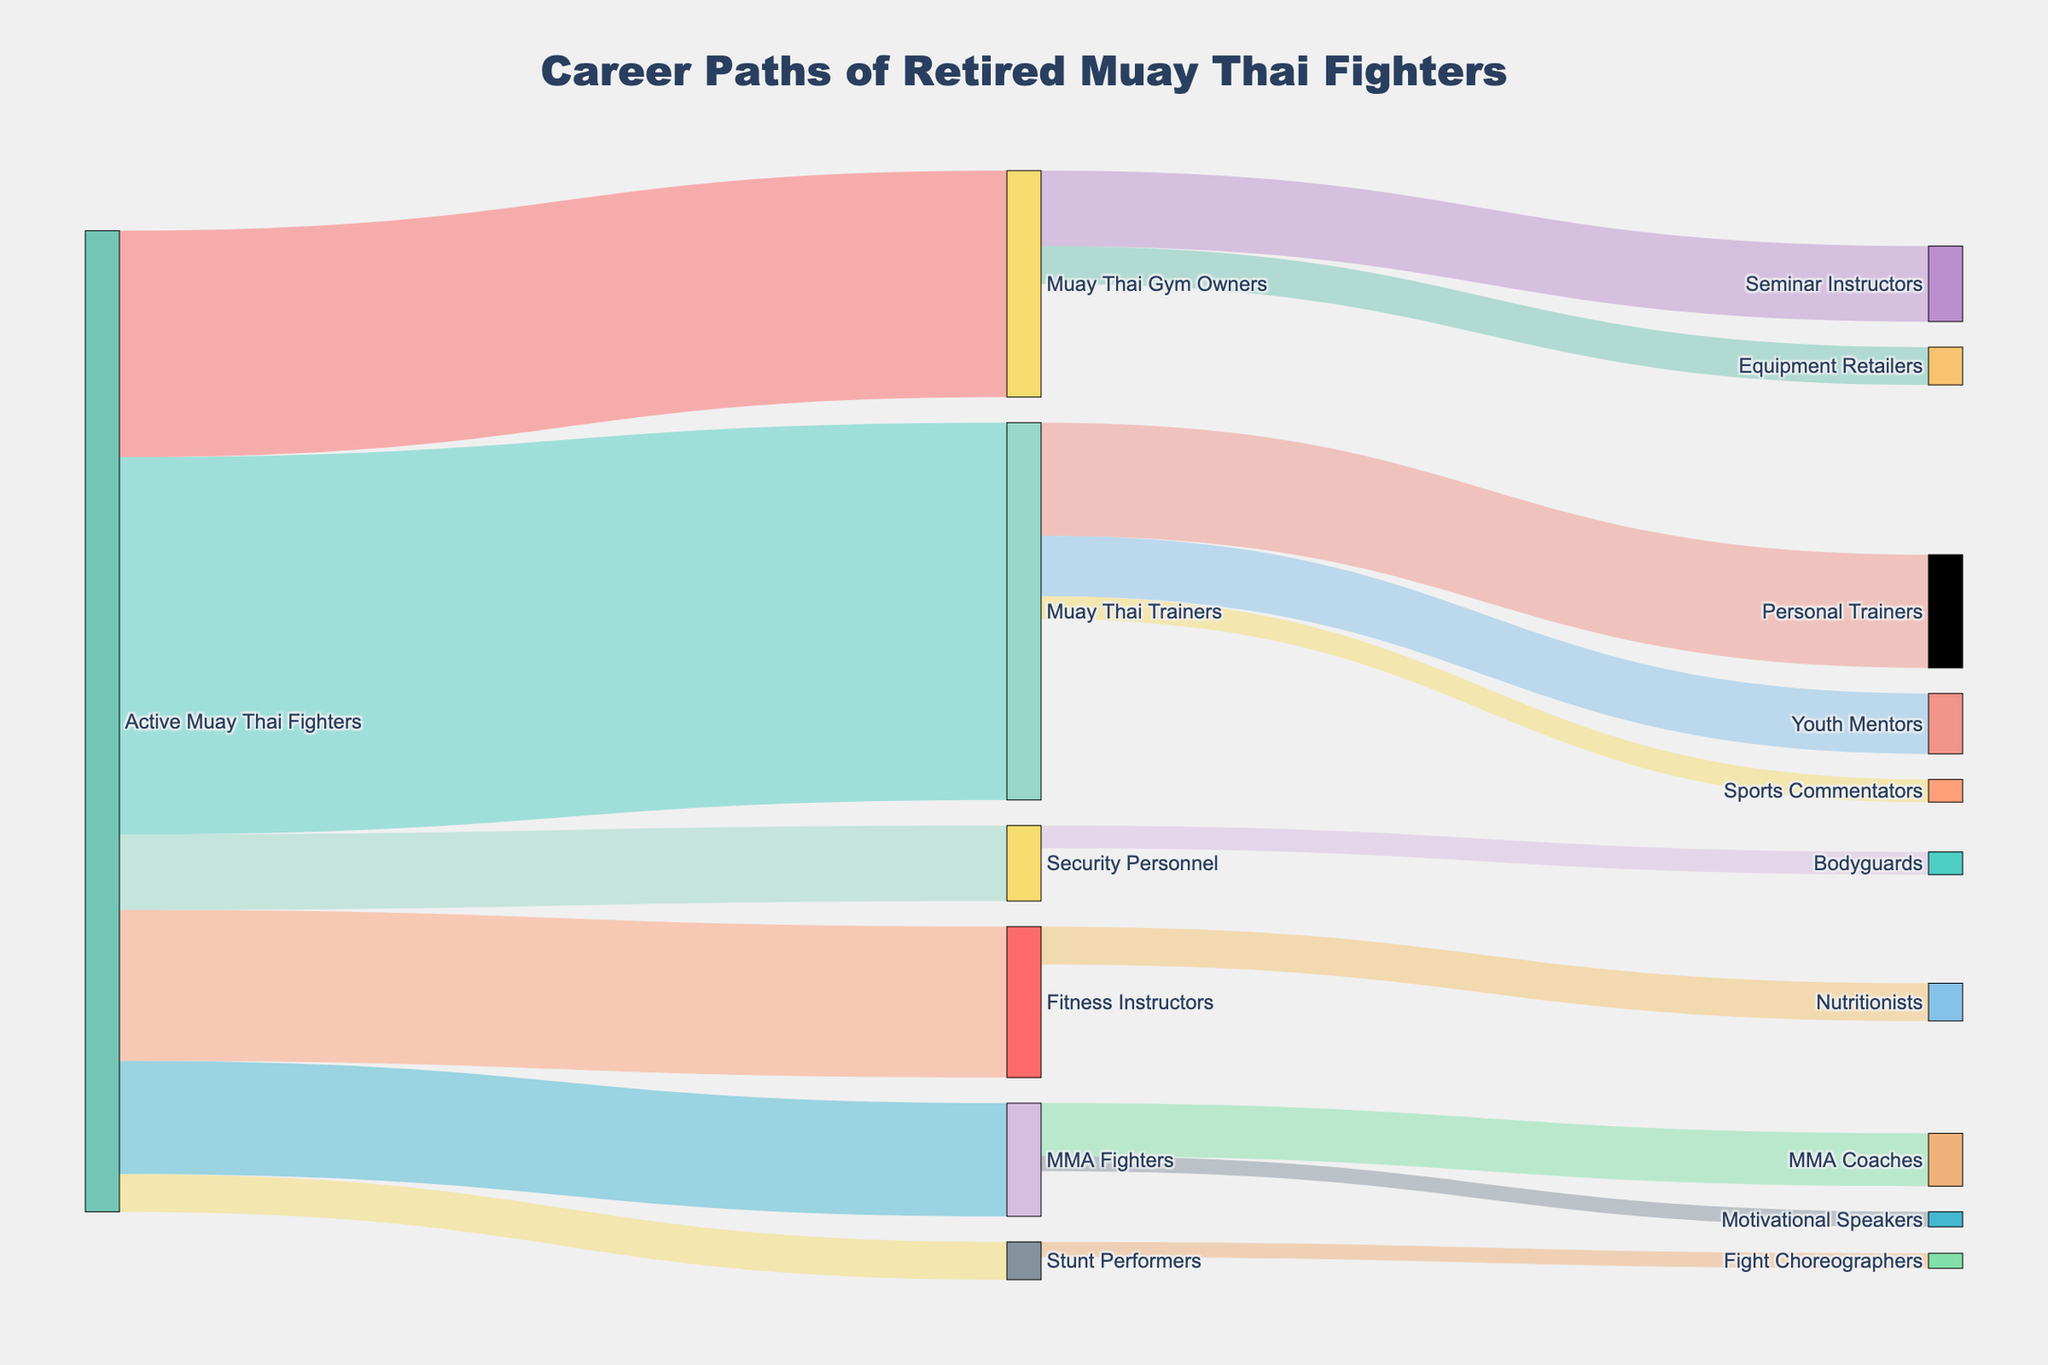what is the highest number of retired Muay Thai fighters transitioning into a single role? From the Sankey diagram, observe the width of the links to determine the transitions with the highest value. The transition from "Active Muay Thai Fighters" to "Muay Thai Trainers" has the highest value of 50.
Answer: 50 How many retired Muay Thai fighters moved into roles outside the realm of Muay Thai directly from being Active Muay Thai Fighters? Summing up the values of transitions from "Active Muay Thai Fighters" to roles outside Muay Thai such as "MMA Fighters" (15), "Fitness Instructors" (20), "Security Personnel" (10), and "Stunt Performers" (5). This totals to 15 + 20 + 10 + 5 = 50.
Answer: 50 What proportion of retired Muay Thai fighters become Muay Thai Trainers compared to those becoming Muay Thai Gym Owners? The number of fighters transitioning to Muay Thai Trainers is 50 and those becoming Muay Thai Gym Owners is 30. The proportion is calculated as 50/30.
Answer: 50/30 What is the sum of the fighters who become Seminar Instructors and those who become Personal Trainers? Adding the values transitioning to these roles: 10 (Seminar Instructors) + 15 (Personal Trainers). Therefore, 10 + 15 = 25.
Answer: 25 How many different roles do retired Muay Thai fighters transition into from being Active Muay Thai Fighters? Count the distinct roles that Active Muay Thai Fighters transition into: Muay Thai Gym Owners, Muay Thai Trainers, MMA Fighters, Fitness Instructors, Security Personnel, Stunt Performers. So there are 6 roles in total.
Answer: 6 Which role has fewer transitions: Youth Mentors or Fight Choreographers? Comparing the transitions: Youth Mentors 8, Fight Choreographers 2. Fight Choreographers have fewer transitions.
Answer: Fight Choreographers How many fighters from Muay Thai Trainers transition to roles outside Muay Thai? Sum the values transitioning from Muay Thai Trainers to roles outside Muay Thai: Personal Trainers (15), Sports Commentators (3). Summing these gives 15 + 3 = 18.
Answer: 18 Which role gets the fewest retired fighters from any previous active roles? Observing the Sankey diagram, Fight Choreographers get the fewest with a value of 2.
Answer: Fight Choreographers What is the second most common role for retired Muay Thai fighters? From the diagram, the most common role is Muay Thai Trainers (50). The second most common is Muay Thai Gym Owners (30).
Answer: Muay Thai Gym Owners 